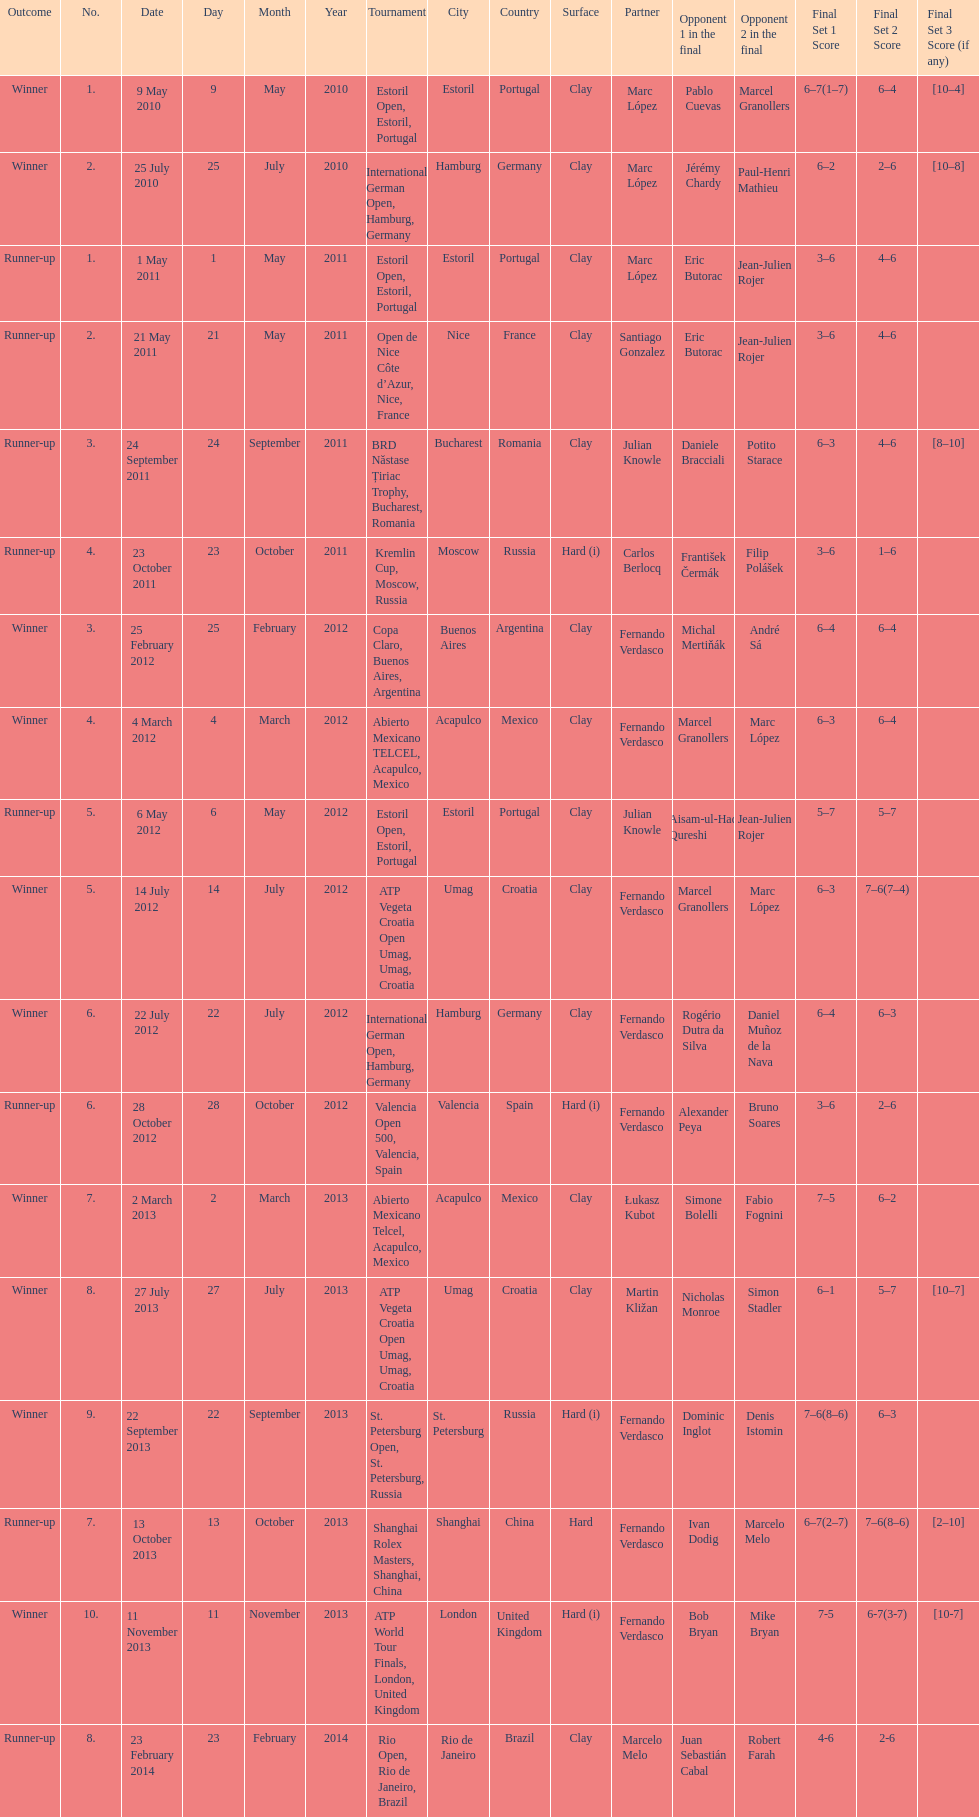How many partners from spain are listed? 2. Give me the full table as a dictionary. {'header': ['Outcome', 'No.', 'Date', 'Day', 'Month', 'Year', 'Tournament', 'City', 'Country', 'Surface', 'Partner', 'Opponent 1 in the final', 'Opponent 2 in the final', 'Final Set 1 Score', 'Final Set 2 Score', 'Final Set 3 Score (if any)'], 'rows': [['Winner', '1.', '9 May 2010', '9', 'May', '2010', 'Estoril Open, Estoril, Portugal', 'Estoril', 'Portugal', 'Clay', 'Marc López', 'Pablo Cuevas', 'Marcel Granollers', '6–7(1–7)', '6–4', '[10–4]'], ['Winner', '2.', '25 July 2010', '25', 'July', '2010', 'International German Open, Hamburg, Germany', 'Hamburg', 'Germany', 'Clay', 'Marc López', 'Jérémy Chardy', 'Paul-Henri Mathieu', '6–2', '2–6', '[10–8]'], ['Runner-up', '1.', '1 May 2011', '1', 'May', '2011', 'Estoril Open, Estoril, Portugal', 'Estoril', 'Portugal', 'Clay', 'Marc López', 'Eric Butorac', 'Jean-Julien Rojer', '3–6', '4–6', ''], ['Runner-up', '2.', '21 May 2011', '21', 'May', '2011', 'Open de Nice Côte d’Azur, Nice, France', 'Nice', 'France', 'Clay', 'Santiago Gonzalez', 'Eric Butorac', 'Jean-Julien Rojer', '3–6', '4–6', ''], ['Runner-up', '3.', '24 September 2011', '24', 'September', '2011', 'BRD Năstase Țiriac Trophy, Bucharest, Romania', 'Bucharest', 'Romania', 'Clay', 'Julian Knowle', 'Daniele Bracciali', 'Potito Starace', '6–3', '4–6', '[8–10]'], ['Runner-up', '4.', '23 October 2011', '23', 'October', '2011', 'Kremlin Cup, Moscow, Russia', 'Moscow', 'Russia', 'Hard (i)', 'Carlos Berlocq', 'František Čermák', 'Filip Polášek', '3–6', '1–6', ''], ['Winner', '3.', '25 February 2012', '25', 'February', '2012', 'Copa Claro, Buenos Aires, Argentina', 'Buenos Aires', 'Argentina', 'Clay', 'Fernando Verdasco', 'Michal Mertiňák', 'André Sá', '6–4', '6–4', ''], ['Winner', '4.', '4 March 2012', '4', 'March', '2012', 'Abierto Mexicano TELCEL, Acapulco, Mexico', 'Acapulco', 'Mexico', 'Clay', 'Fernando Verdasco', 'Marcel Granollers', 'Marc López', '6–3', '6–4', ''], ['Runner-up', '5.', '6 May 2012', '6', 'May', '2012', 'Estoril Open, Estoril, Portugal', 'Estoril', 'Portugal', 'Clay', 'Julian Knowle', 'Aisam-ul-Haq Qureshi', 'Jean-Julien Rojer', '5–7', '5–7', ''], ['Winner', '5.', '14 July 2012', '14', 'July', '2012', 'ATP Vegeta Croatia Open Umag, Umag, Croatia', 'Umag', 'Croatia', 'Clay', 'Fernando Verdasco', 'Marcel Granollers', 'Marc López', '6–3', '7–6(7–4)', ''], ['Winner', '6.', '22 July 2012', '22', 'July', '2012', 'International German Open, Hamburg, Germany', 'Hamburg', 'Germany', 'Clay', 'Fernando Verdasco', 'Rogério Dutra da Silva', 'Daniel Muñoz de la Nava', '6–4', '6–3', ''], ['Runner-up', '6.', '28 October 2012', '28', 'October', '2012', 'Valencia Open 500, Valencia, Spain', 'Valencia', 'Spain', 'Hard (i)', 'Fernando Verdasco', 'Alexander Peya', 'Bruno Soares', '3–6', '2–6', ''], ['Winner', '7.', '2 March 2013', '2', 'March', '2013', 'Abierto Mexicano Telcel, Acapulco, Mexico', 'Acapulco', 'Mexico', 'Clay', 'Łukasz Kubot', 'Simone Bolelli', 'Fabio Fognini', '7–5', '6–2', ''], ['Winner', '8.', '27 July 2013', '27', 'July', '2013', 'ATP Vegeta Croatia Open Umag, Umag, Croatia', 'Umag', 'Croatia', 'Clay', 'Martin Kližan', 'Nicholas Monroe', 'Simon Stadler', '6–1', '5–7', '[10–7]'], ['Winner', '9.', '22 September 2013', '22', 'September', '2013', 'St. Petersburg Open, St. Petersburg, Russia', 'St. Petersburg', 'Russia', 'Hard (i)', 'Fernando Verdasco', 'Dominic Inglot', 'Denis Istomin', '7–6(8–6)', '6–3', ''], ['Runner-up', '7.', '13 October 2013', '13', 'October', '2013', 'Shanghai Rolex Masters, Shanghai, China', 'Shanghai', 'China', 'Hard', 'Fernando Verdasco', 'Ivan Dodig', 'Marcelo Melo', '6–7(2–7)', '7–6(8–6)', '[2–10]'], ['Winner', '10.', '11 November 2013', '11', 'November', '2013', 'ATP World Tour Finals, London, United Kingdom', 'London', 'United Kingdom', 'Hard (i)', 'Fernando Verdasco', 'Bob Bryan', 'Mike Bryan', '7-5', '6-7(3-7)', '[10-7]'], ['Runner-up', '8.', '23 February 2014', '23', 'February', '2014', 'Rio Open, Rio de Janeiro, Brazil', 'Rio de Janeiro', 'Brazil', 'Clay', 'Marcelo Melo', 'Juan Sebastián Cabal', 'Robert Farah', '4-6', '2-6', '']]} 